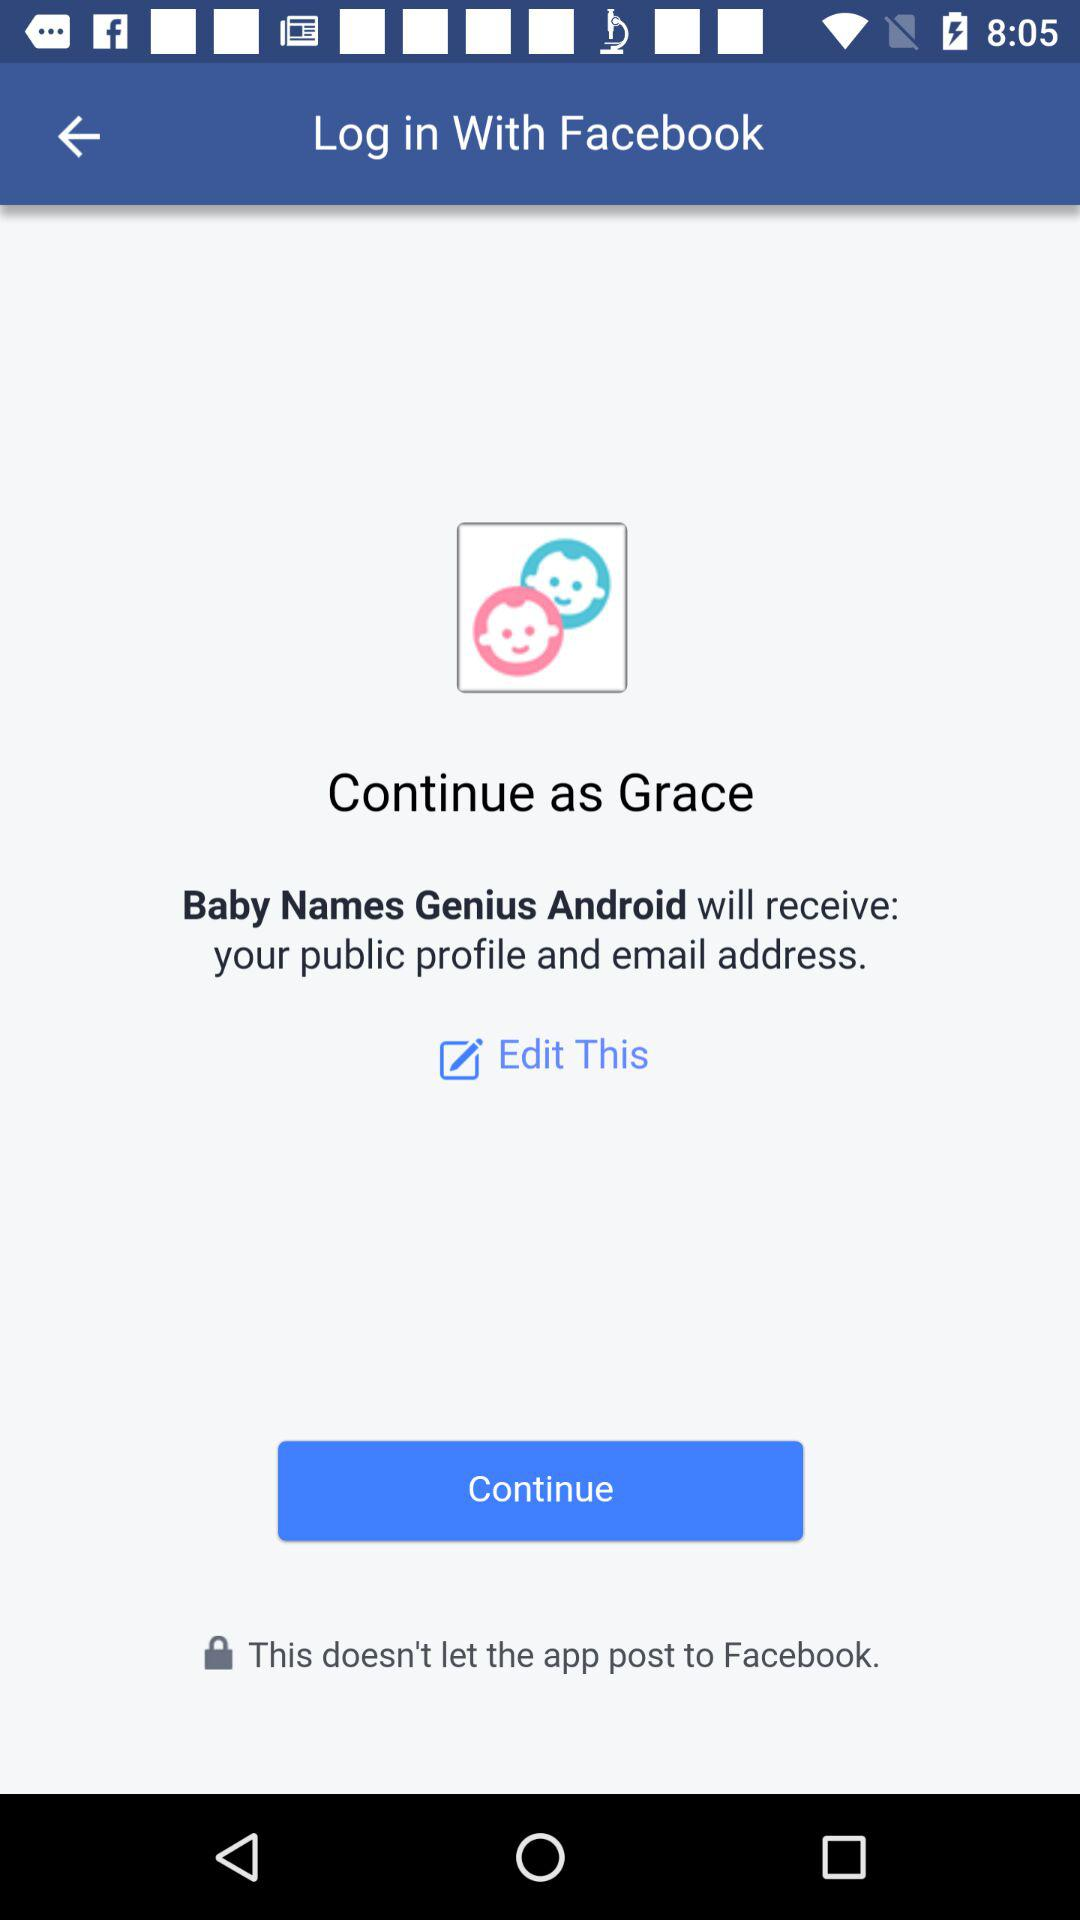What application is asking for permission? The application asking for permission is "Baby Names Genius Android". 